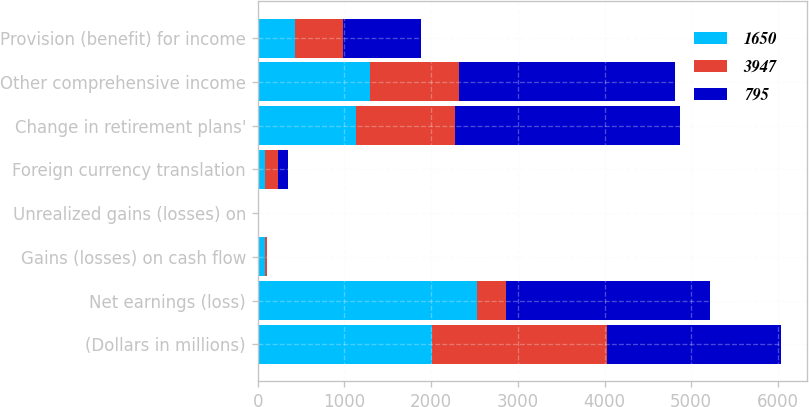Convert chart. <chart><loc_0><loc_0><loc_500><loc_500><stacked_bar_chart><ecel><fcel>(Dollars in millions)<fcel>Net earnings (loss)<fcel>Gains (losses) on cash flow<fcel>Unrealized gains (losses) on<fcel>Foreign currency translation<fcel>Change in retirement plans'<fcel>Other comprehensive income<fcel>Provision (benefit) for income<nl><fcel>1650<fcel>2011<fcel>2526<fcel>81<fcel>1<fcel>89<fcel>1129<fcel>1300<fcel>424<nl><fcel>3947<fcel>2012<fcel>332<fcel>23<fcel>6<fcel>141<fcel>1149<fcel>1025<fcel>562<nl><fcel>795<fcel>2013<fcel>2357<fcel>3<fcel>12<fcel>118<fcel>2595<fcel>2492<fcel>902<nl></chart> 